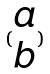Convert formula to latex. <formula><loc_0><loc_0><loc_500><loc_500>( \begin{matrix} a \\ b \end{matrix} )</formula> 